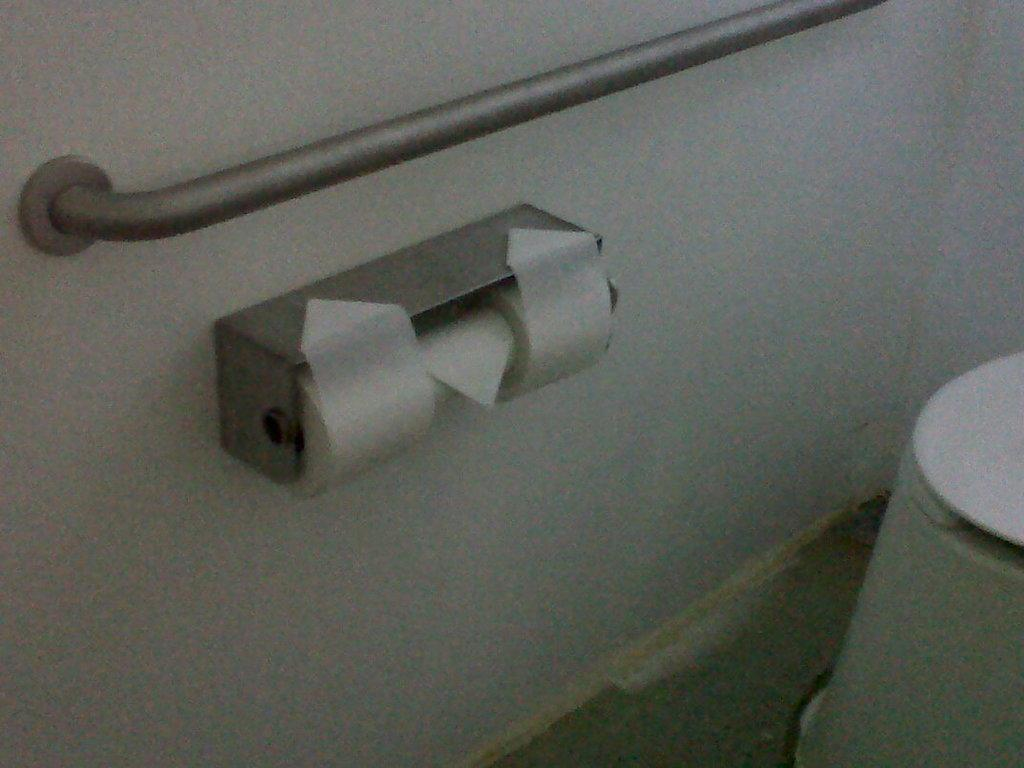What is present on the wall in the image? There is a hanger rod and a tissue roll on the wall in the image. Can you describe the other object on the wall? Unfortunately, the facts provided do not give any information about another object on the wall. What is the purpose of the hanger rod on the wall? The hanger rod on the wall is likely used for hanging clothes or other items. What is the object on a surface in the image? The facts provided mention that there is another object on a surface in the image, but no specific details are given about its appearance or purpose. What is the opinion of the tissue roll on the wall? The tissue roll does not have an opinion, as it is an inanimate object. What type of science experiment can be seen in the image? There is no science experiment present in the image; it only features a wall with a hanger rod and a tissue roll. 